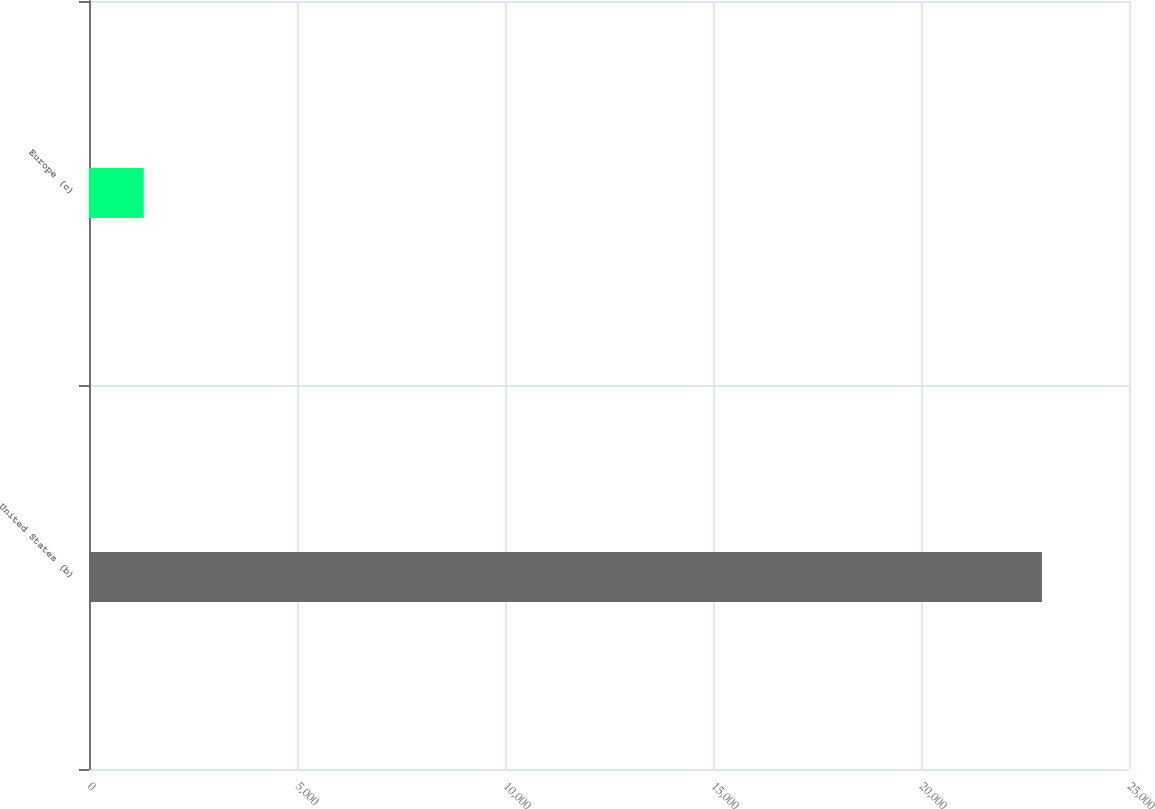<chart> <loc_0><loc_0><loc_500><loc_500><bar_chart><fcel>United States (b)<fcel>Europe (c)<nl><fcel>22908<fcel>1317<nl></chart> 